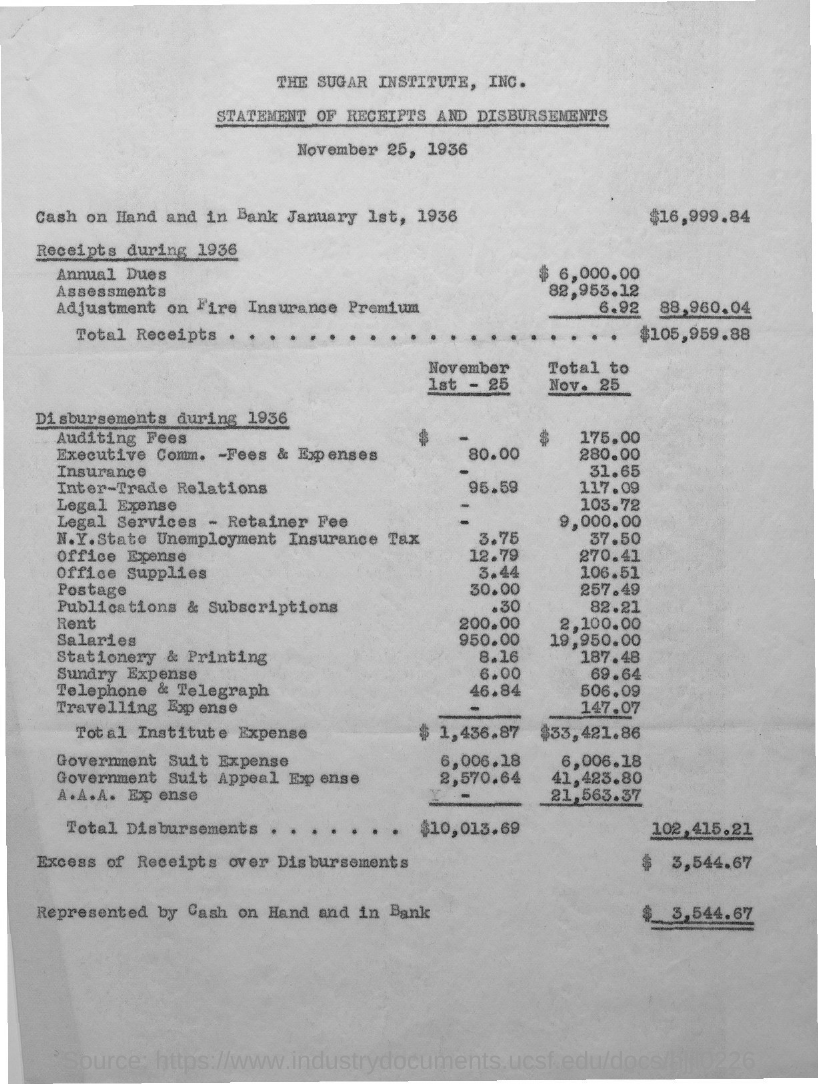Identify some key points in this picture. The title of this document is 'Statement of Receipts and Disbursements.' The adjustment on the fire insurance premium is 6.92. The annual dues are $6,000.00. The amount of the excess of receipts over disbursements is $3,544.67. On January 1st, 1936, the cash on hand and in the bank was $16,999.84. 